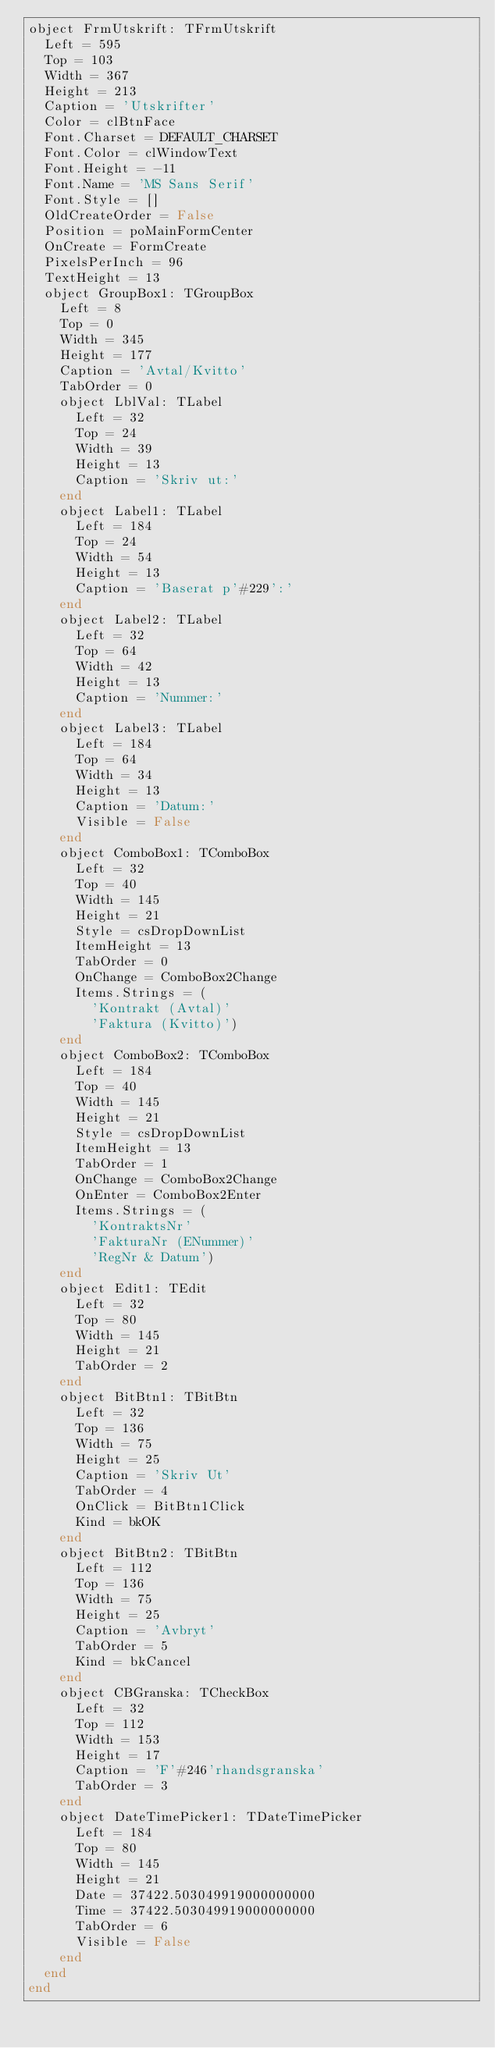Convert code to text. <code><loc_0><loc_0><loc_500><loc_500><_Pascal_>object FrmUtskrift: TFrmUtskrift
  Left = 595
  Top = 103
  Width = 367
  Height = 213
  Caption = 'Utskrifter'
  Color = clBtnFace
  Font.Charset = DEFAULT_CHARSET
  Font.Color = clWindowText
  Font.Height = -11
  Font.Name = 'MS Sans Serif'
  Font.Style = []
  OldCreateOrder = False
  Position = poMainFormCenter
  OnCreate = FormCreate
  PixelsPerInch = 96
  TextHeight = 13
  object GroupBox1: TGroupBox
    Left = 8
    Top = 0
    Width = 345
    Height = 177
    Caption = 'Avtal/Kvitto'
    TabOrder = 0
    object LblVal: TLabel
      Left = 32
      Top = 24
      Width = 39
      Height = 13
      Caption = 'Skriv ut:'
    end
    object Label1: TLabel
      Left = 184
      Top = 24
      Width = 54
      Height = 13
      Caption = 'Baserat p'#229':'
    end
    object Label2: TLabel
      Left = 32
      Top = 64
      Width = 42
      Height = 13
      Caption = 'Nummer:'
    end
    object Label3: TLabel
      Left = 184
      Top = 64
      Width = 34
      Height = 13
      Caption = 'Datum:'
      Visible = False
    end
    object ComboBox1: TComboBox
      Left = 32
      Top = 40
      Width = 145
      Height = 21
      Style = csDropDownList
      ItemHeight = 13
      TabOrder = 0
      OnChange = ComboBox2Change
      Items.Strings = (
        'Kontrakt (Avtal)'
        'Faktura (Kvitto)')
    end
    object ComboBox2: TComboBox
      Left = 184
      Top = 40
      Width = 145
      Height = 21
      Style = csDropDownList
      ItemHeight = 13
      TabOrder = 1
      OnChange = ComboBox2Change
      OnEnter = ComboBox2Enter
      Items.Strings = (
        'KontraktsNr'
        'FakturaNr (ENummer)'
        'RegNr & Datum')
    end
    object Edit1: TEdit
      Left = 32
      Top = 80
      Width = 145
      Height = 21
      TabOrder = 2
    end
    object BitBtn1: TBitBtn
      Left = 32
      Top = 136
      Width = 75
      Height = 25
      Caption = 'Skriv Ut'
      TabOrder = 4
      OnClick = BitBtn1Click
      Kind = bkOK
    end
    object BitBtn2: TBitBtn
      Left = 112
      Top = 136
      Width = 75
      Height = 25
      Caption = 'Avbryt'
      TabOrder = 5
      Kind = bkCancel
    end
    object CBGranska: TCheckBox
      Left = 32
      Top = 112
      Width = 153
      Height = 17
      Caption = 'F'#246'rhandsgranska'
      TabOrder = 3
    end
    object DateTimePicker1: TDateTimePicker
      Left = 184
      Top = 80
      Width = 145
      Height = 21
      Date = 37422.503049919000000000
      Time = 37422.503049919000000000
      TabOrder = 6
      Visible = False
    end
  end
end
</code> 